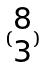Convert formula to latex. <formula><loc_0><loc_0><loc_500><loc_500>( \begin{matrix} 8 \\ 3 \end{matrix} )</formula> 